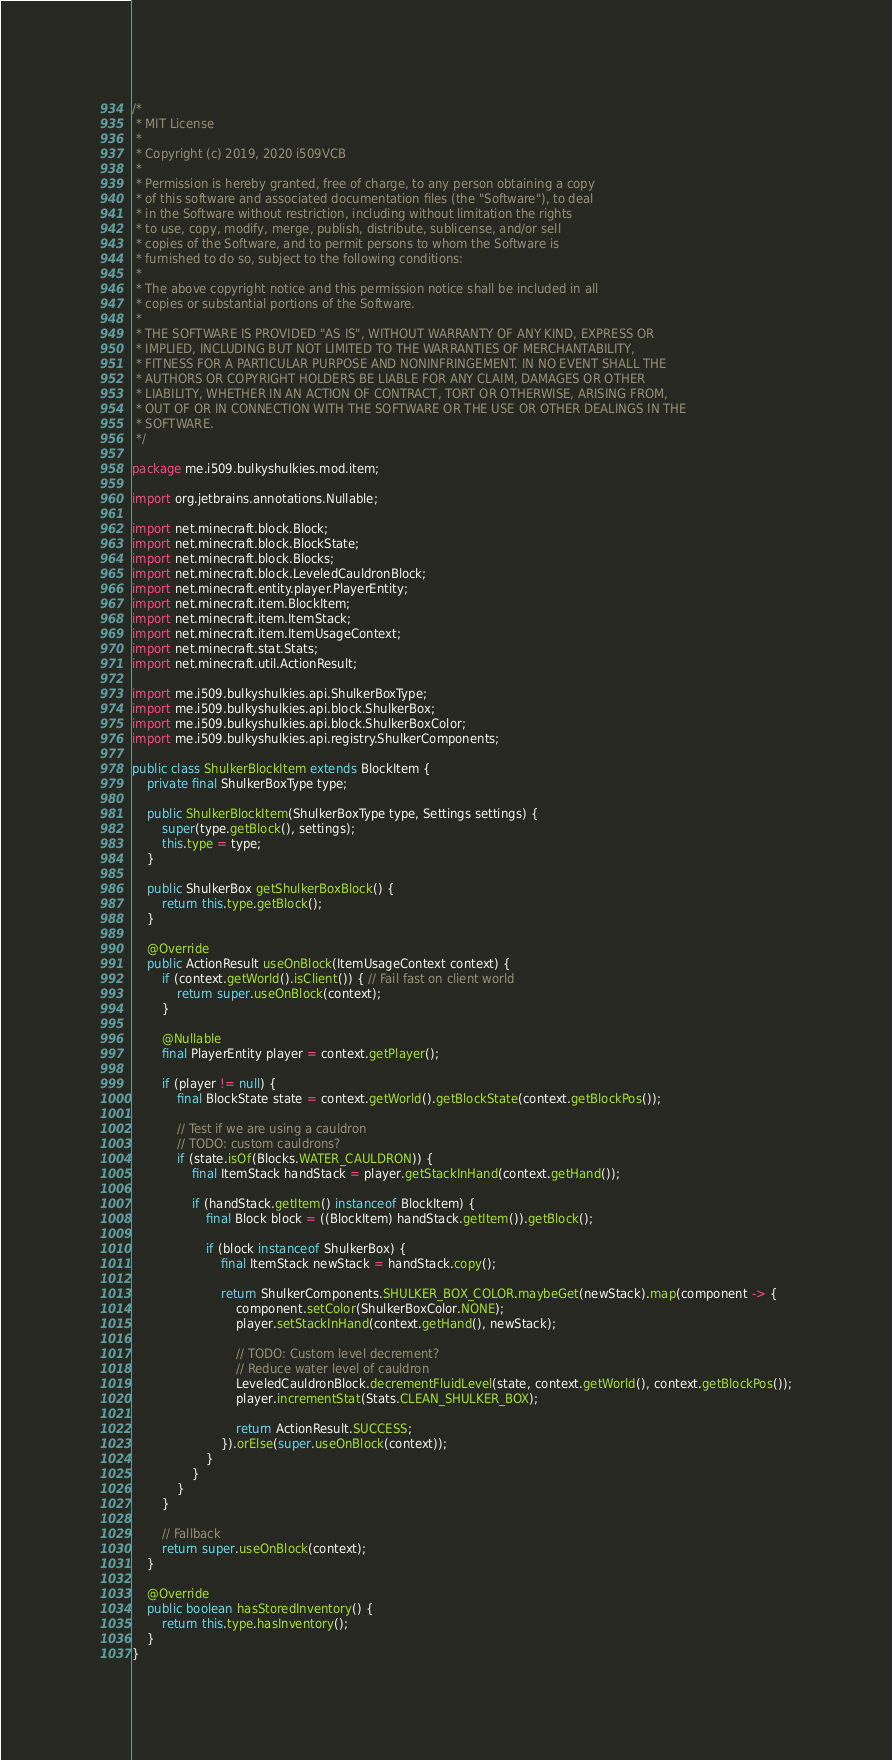<code> <loc_0><loc_0><loc_500><loc_500><_Java_>/*
 * MIT License
 *
 * Copyright (c) 2019, 2020 i509VCB
 *
 * Permission is hereby granted, free of charge, to any person obtaining a copy
 * of this software and associated documentation files (the "Software"), to deal
 * in the Software without restriction, including without limitation the rights
 * to use, copy, modify, merge, publish, distribute, sublicense, and/or sell
 * copies of the Software, and to permit persons to whom the Software is
 * furnished to do so, subject to the following conditions:
 *
 * The above copyright notice and this permission notice shall be included in all
 * copies or substantial portions of the Software.
 *
 * THE SOFTWARE IS PROVIDED "AS IS", WITHOUT WARRANTY OF ANY KIND, EXPRESS OR
 * IMPLIED, INCLUDING BUT NOT LIMITED TO THE WARRANTIES OF MERCHANTABILITY,
 * FITNESS FOR A PARTICULAR PURPOSE AND NONINFRINGEMENT. IN NO EVENT SHALL THE
 * AUTHORS OR COPYRIGHT HOLDERS BE LIABLE FOR ANY CLAIM, DAMAGES OR OTHER
 * LIABILITY, WHETHER IN AN ACTION OF CONTRACT, TORT OR OTHERWISE, ARISING FROM,
 * OUT OF OR IN CONNECTION WITH THE SOFTWARE OR THE USE OR OTHER DEALINGS IN THE
 * SOFTWARE.
 */

package me.i509.bulkyshulkies.mod.item;

import org.jetbrains.annotations.Nullable;

import net.minecraft.block.Block;
import net.minecraft.block.BlockState;
import net.minecraft.block.Blocks;
import net.minecraft.block.LeveledCauldronBlock;
import net.minecraft.entity.player.PlayerEntity;
import net.minecraft.item.BlockItem;
import net.minecraft.item.ItemStack;
import net.minecraft.item.ItemUsageContext;
import net.minecraft.stat.Stats;
import net.minecraft.util.ActionResult;

import me.i509.bulkyshulkies.api.ShulkerBoxType;
import me.i509.bulkyshulkies.api.block.ShulkerBox;
import me.i509.bulkyshulkies.api.block.ShulkerBoxColor;
import me.i509.bulkyshulkies.api.registry.ShulkerComponents;

public class ShulkerBlockItem extends BlockItem {
	private final ShulkerBoxType type;

	public ShulkerBlockItem(ShulkerBoxType type, Settings settings) {
		super(type.getBlock(), settings);
		this.type = type;
	}

	public ShulkerBox getShulkerBoxBlock() {
		return this.type.getBlock();
	}

	@Override
	public ActionResult useOnBlock(ItemUsageContext context) {
		if (context.getWorld().isClient()) { // Fail fast on client world
			return super.useOnBlock(context);
		}

		@Nullable
		final PlayerEntity player = context.getPlayer();

		if (player != null) {
			final BlockState state = context.getWorld().getBlockState(context.getBlockPos());

			// Test if we are using a cauldron
			// TODO: custom cauldrons?
			if (state.isOf(Blocks.WATER_CAULDRON)) {
				final ItemStack handStack = player.getStackInHand(context.getHand());

				if (handStack.getItem() instanceof BlockItem) {
					final Block block = ((BlockItem) handStack.getItem()).getBlock();

					if (block instanceof ShulkerBox) {
						final ItemStack newStack = handStack.copy();

						return ShulkerComponents.SHULKER_BOX_COLOR.maybeGet(newStack).map(component -> {
							component.setColor(ShulkerBoxColor.NONE);
							player.setStackInHand(context.getHand(), newStack);

							// TODO: Custom level decrement?
							// Reduce water level of cauldron
							LeveledCauldronBlock.decrementFluidLevel(state, context.getWorld(), context.getBlockPos());
							player.incrementStat(Stats.CLEAN_SHULKER_BOX);

							return ActionResult.SUCCESS;
						}).orElse(super.useOnBlock(context));
					}
				}
			}
		}

		// Fallback
		return super.useOnBlock(context);
	}

	@Override
	public boolean hasStoredInventory() {
		return this.type.hasInventory();
	}
}
</code> 